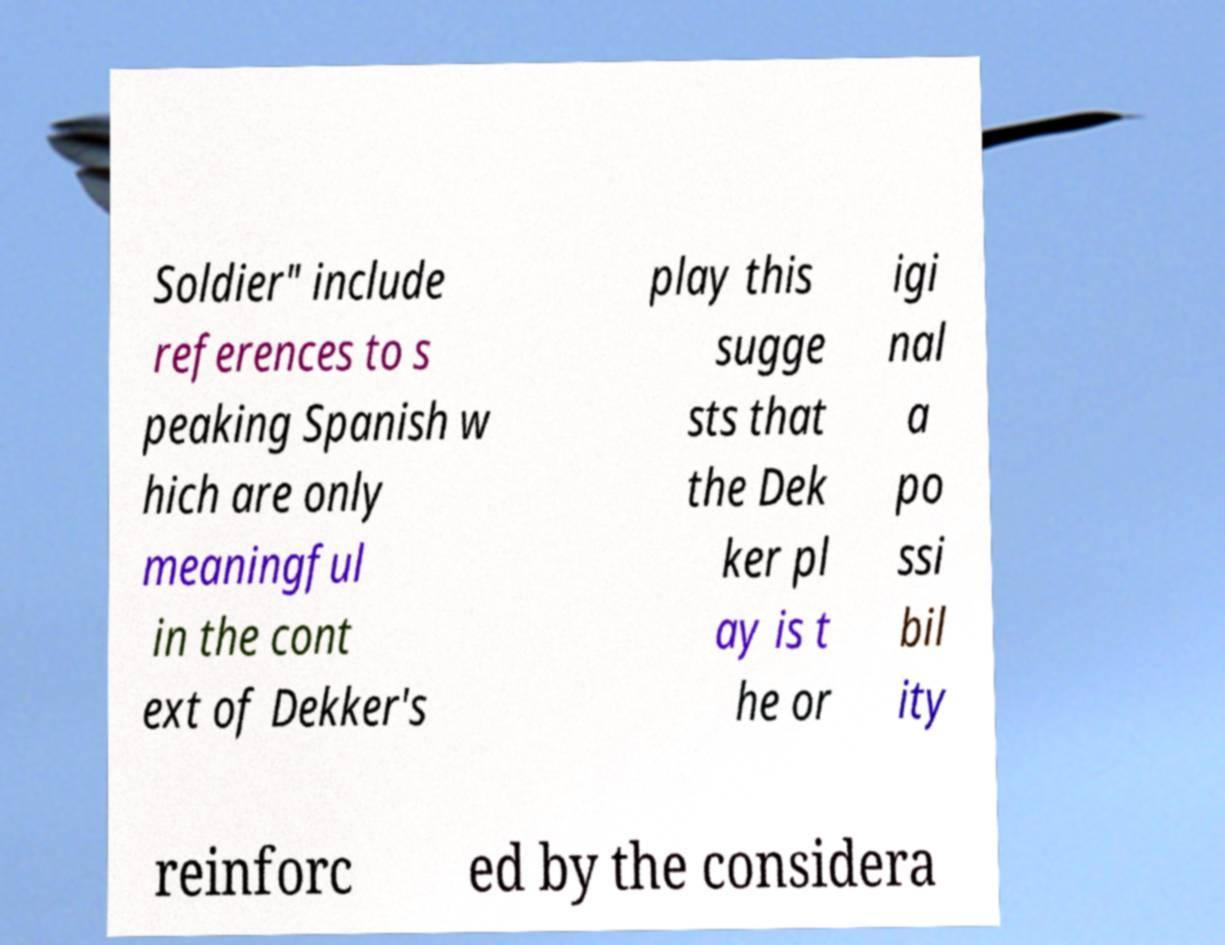For documentation purposes, I need the text within this image transcribed. Could you provide that? Soldier" include references to s peaking Spanish w hich are only meaningful in the cont ext of Dekker's play this sugge sts that the Dek ker pl ay is t he or igi nal a po ssi bil ity reinforc ed by the considera 